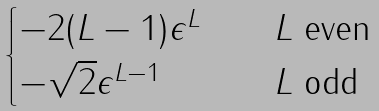Convert formula to latex. <formula><loc_0><loc_0><loc_500><loc_500>\begin{cases} - 2 ( L - 1 ) \epsilon ^ { L } & \quad \text {$L$ even} \\ - \sqrt { 2 } \epsilon ^ { L - 1 } & \quad \text {$L$ odd} \end{cases}</formula> 